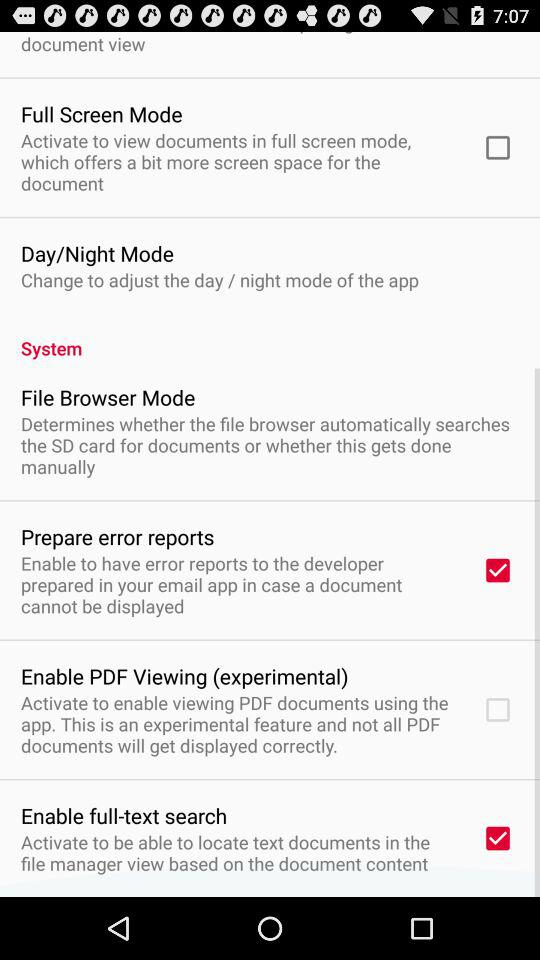How many items have checkboxes?
Answer the question using a single word or phrase. 4 